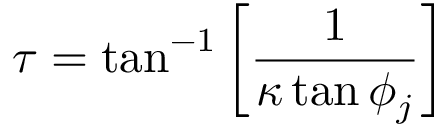<formula> <loc_0><loc_0><loc_500><loc_500>\tau = \tan ^ { - 1 } \left [ \frac { 1 } { \kappa \tan \phi _ { j } } \right ]</formula> 